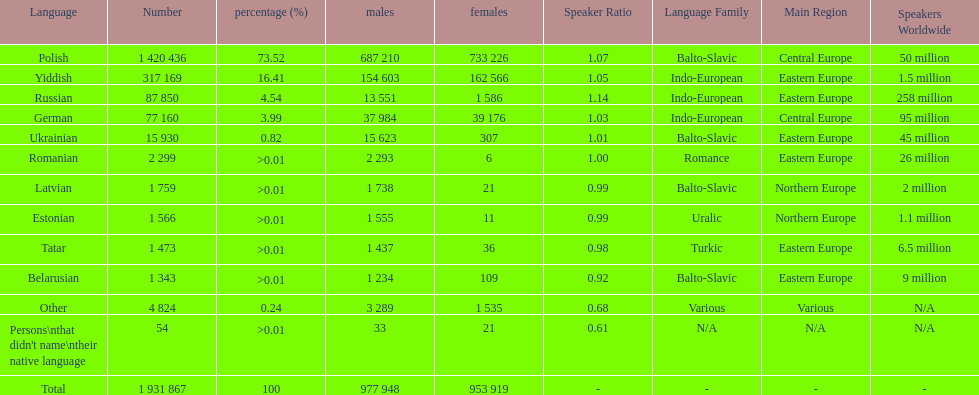Number of male russian speakers 13 551. 